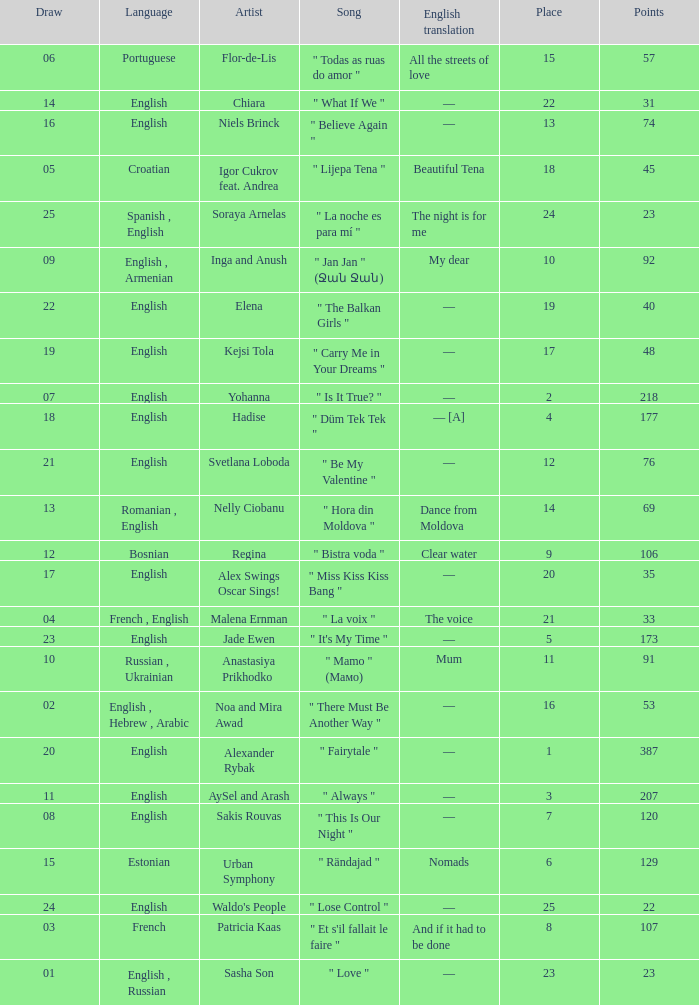What song was in french? " Et s'il fallait le faire ". 